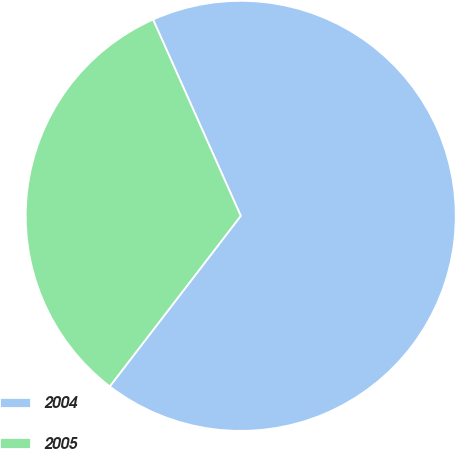<chart> <loc_0><loc_0><loc_500><loc_500><pie_chart><fcel>2004<fcel>2005<nl><fcel>67.11%<fcel>32.89%<nl></chart> 